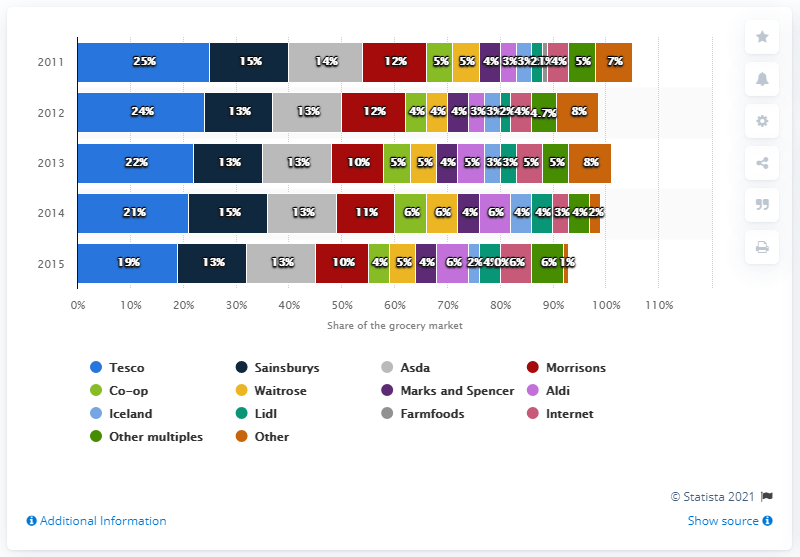Give some essential details in this illustration. According to Kantar Worldpanel, Aldi is the fifth largest supermarket in the United Kingdom. 